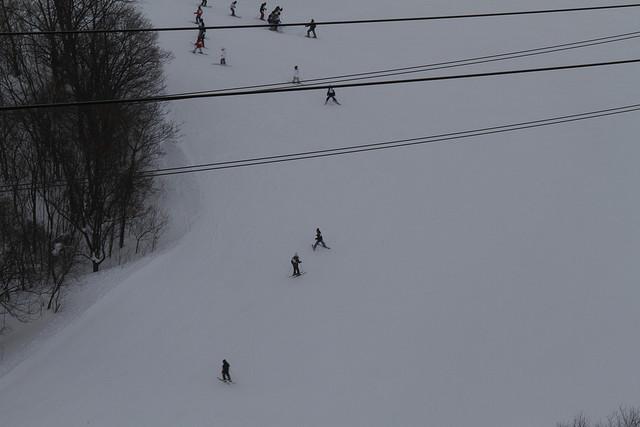Where are there wires?
Write a very short answer. Air. How many people are going down the hill?
Answer briefly. 12. What is the direction of the black lines on the picture?
Answer briefly. Horizontal. Is there snow on the wires?
Write a very short answer. No. Is this snowy?
Concise answer only. Yes. 